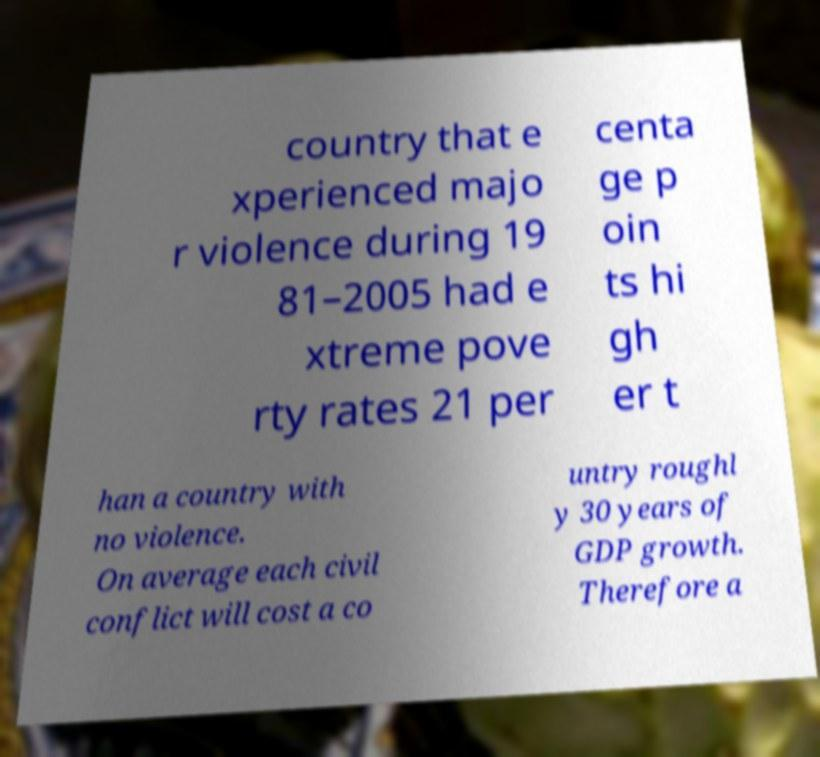Please identify and transcribe the text found in this image. country that e xperienced majo r violence during 19 81–2005 had e xtreme pove rty rates 21 per centa ge p oin ts hi gh er t han a country with no violence. On average each civil conflict will cost a co untry roughl y 30 years of GDP growth. Therefore a 